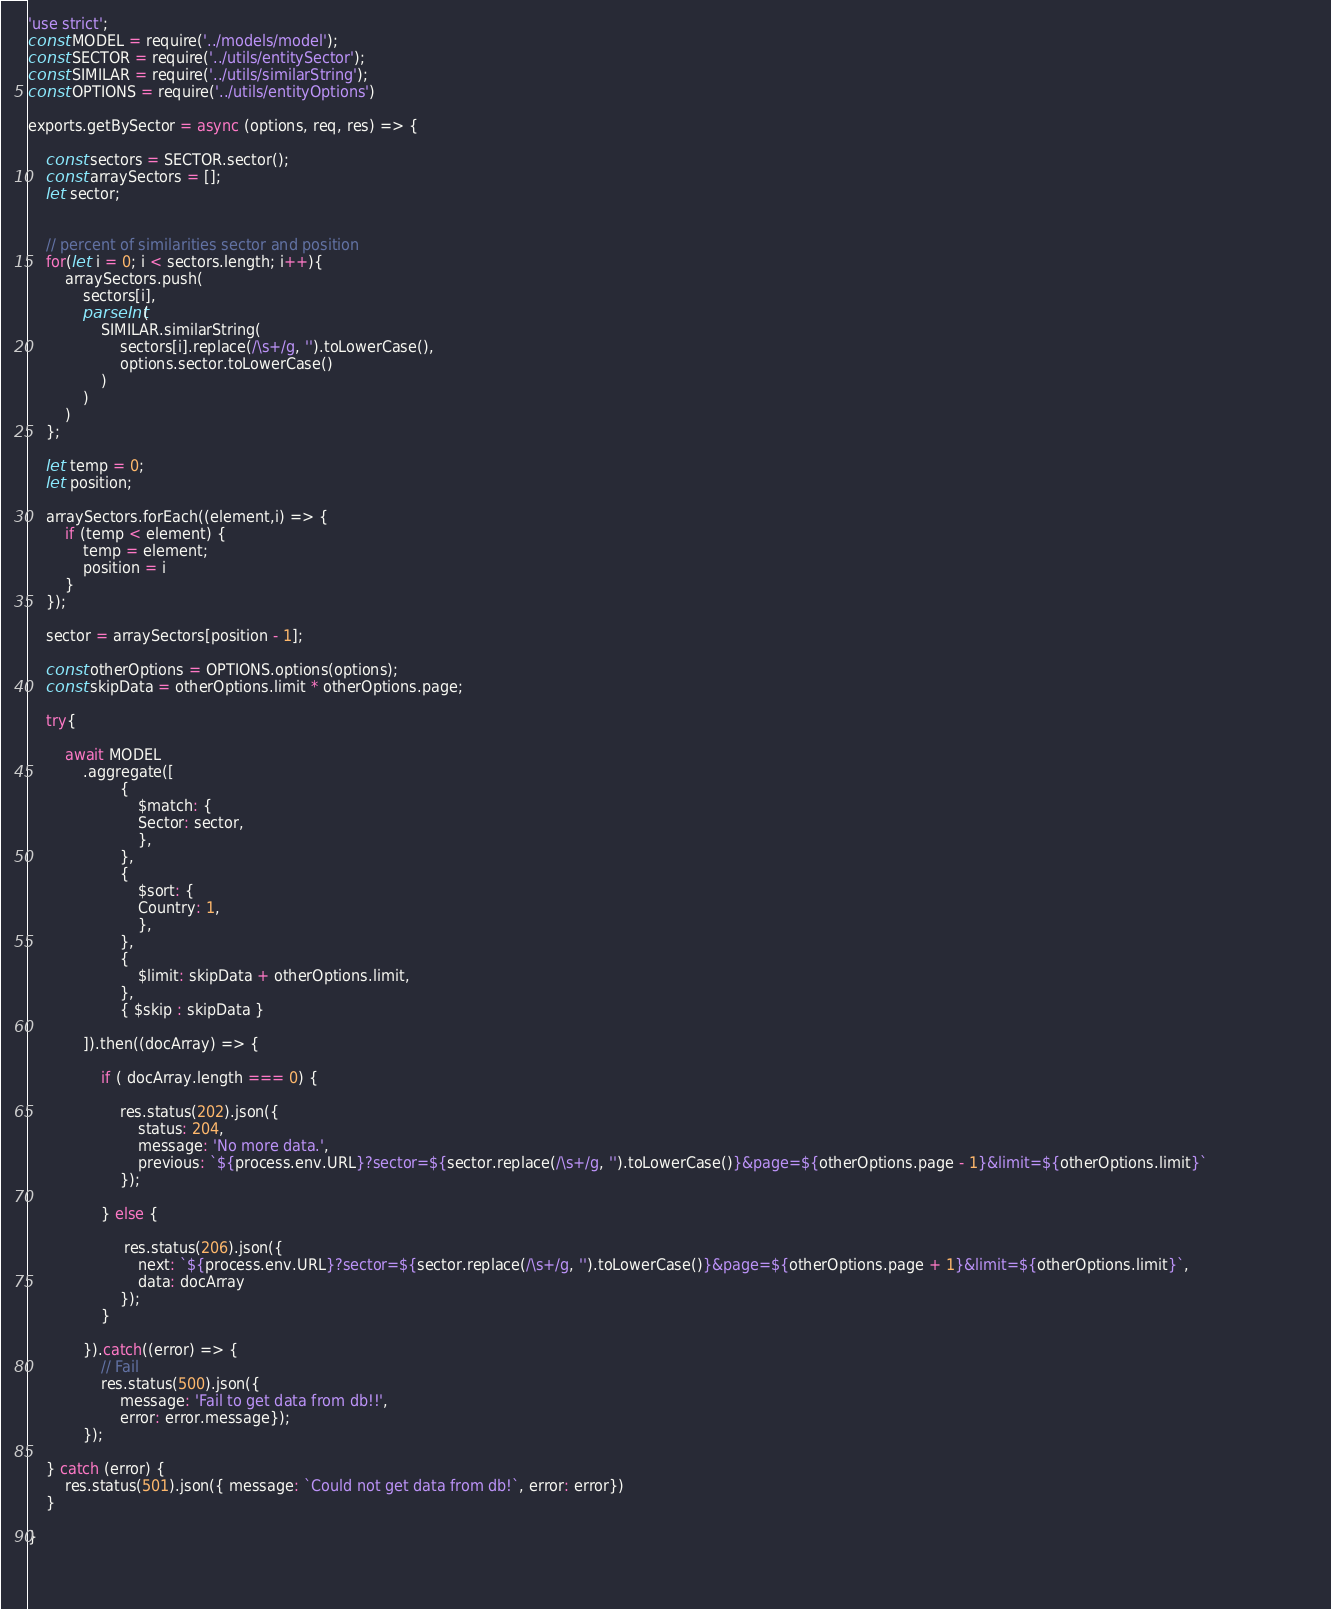<code> <loc_0><loc_0><loc_500><loc_500><_JavaScript_>'use strict';
const MODEL = require('../models/model');
const SECTOR = require('../utils/entitySector');
const SIMILAR = require('../utils/similarString');
const OPTIONS = require('../utils/entityOptions')

exports.getBySector = async (options, req, res) => {

    const sectors = SECTOR.sector();
    const arraySectors = [];
    let sector;
    

    // percent of similarities sector and position
    for(let i = 0; i < sectors.length; i++){  
        arraySectors.push(
            sectors[i], 
            parseInt(
                SIMILAR.similarString(
                    sectors[i].replace(/\s+/g, '').toLowerCase(),
                    options.sector.toLowerCase()
                )
            )
        )      
    };

    let temp = 0;
    let position;

    arraySectors.forEach((element,i) => {
        if (temp < element) {
            temp = element;
            position = i
        }
    });
     
    sector = arraySectors[position - 1];

    const otherOptions = OPTIONS.options(options);
    const skipData = otherOptions.limit * otherOptions.page;  

    try{
        
        await MODEL
            .aggregate([
                    {
                        $match: {
                        Sector: sector,
                        },
                    },
                    {
                        $sort: {
                        Country: 1,
                        },
                    },
                    {
                        $limit: skipData + otherOptions.limit,
                    },
                    { $skip : skipData }

            ]).then((docArray) => {

                if ( docArray.length === 0) {

                    res.status(202).json({
                        status: 204,
                        message: 'No more data.',
                        previous: `${process.env.URL}?sector=${sector.replace(/\s+/g, '').toLowerCase()}&page=${otherOptions.page - 1}&limit=${otherOptions.limit}`                        
                    });
        
                } else {

                     res.status(206).json({
                        next: `${process.env.URL}?sector=${sector.replace(/\s+/g, '').toLowerCase()}&page=${otherOptions.page + 1}&limit=${otherOptions.limit}`, 
                        data: docArray 
                    });
                }

            }).catch((error) => {     
                // Fail
                res.status(500).json({ 
                    message: 'Fail to get data from db!!', 
                    error: error.message});
            });

    } catch (error) {
        res.status(501).json({ message: `Could not get data from db!`, error: error})
    }

}


            
</code> 